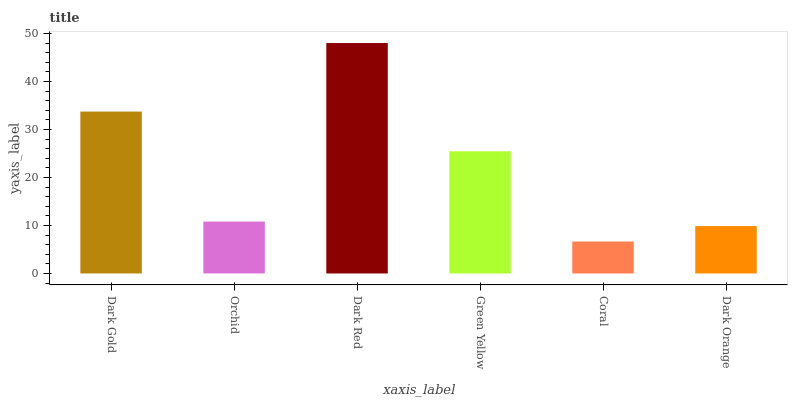Is Coral the minimum?
Answer yes or no. Yes. Is Dark Red the maximum?
Answer yes or no. Yes. Is Orchid the minimum?
Answer yes or no. No. Is Orchid the maximum?
Answer yes or no. No. Is Dark Gold greater than Orchid?
Answer yes or no. Yes. Is Orchid less than Dark Gold?
Answer yes or no. Yes. Is Orchid greater than Dark Gold?
Answer yes or no. No. Is Dark Gold less than Orchid?
Answer yes or no. No. Is Green Yellow the high median?
Answer yes or no. Yes. Is Orchid the low median?
Answer yes or no. Yes. Is Dark Red the high median?
Answer yes or no. No. Is Dark Orange the low median?
Answer yes or no. No. 